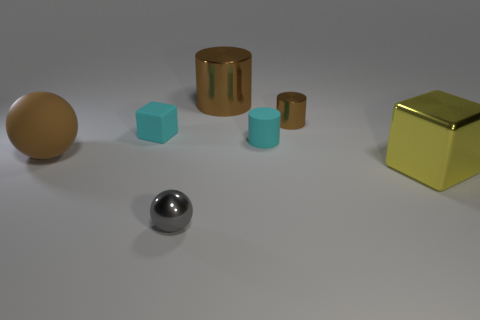Subtract all tiny cylinders. How many cylinders are left? 1 Add 3 small brown matte cylinders. How many objects exist? 10 Subtract all blocks. How many objects are left? 5 Subtract 2 cylinders. How many cylinders are left? 1 Subtract all gray cylinders. Subtract all red blocks. How many cylinders are left? 3 Subtract all yellow blocks. How many gray spheres are left? 1 Subtract all balls. Subtract all brown cylinders. How many objects are left? 3 Add 1 cyan matte cubes. How many cyan matte cubes are left? 2 Add 4 brown metal objects. How many brown metal objects exist? 6 Subtract all cyan cylinders. How many cylinders are left? 2 